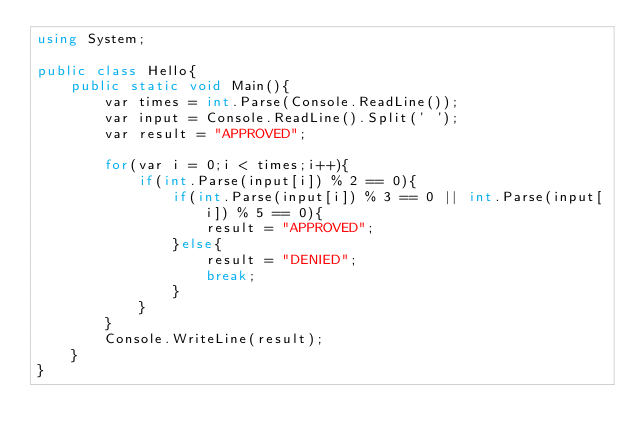<code> <loc_0><loc_0><loc_500><loc_500><_C#_>using System;

public class Hello{
    public static void Main(){
        var times = int.Parse(Console.ReadLine());
        var input = Console.ReadLine().Split(' ');
        var result = "APPROVED";
        
        for(var i = 0;i < times;i++){
            if(int.Parse(input[i]) % 2 == 0){
                if(int.Parse(input[i]) % 3 == 0 || int.Parse(input[i]) % 5 == 0){
                    result = "APPROVED";
                }else{
                    result = "DENIED";
                    break;
                }
            }
        }
        Console.WriteLine(result);
    }
}</code> 